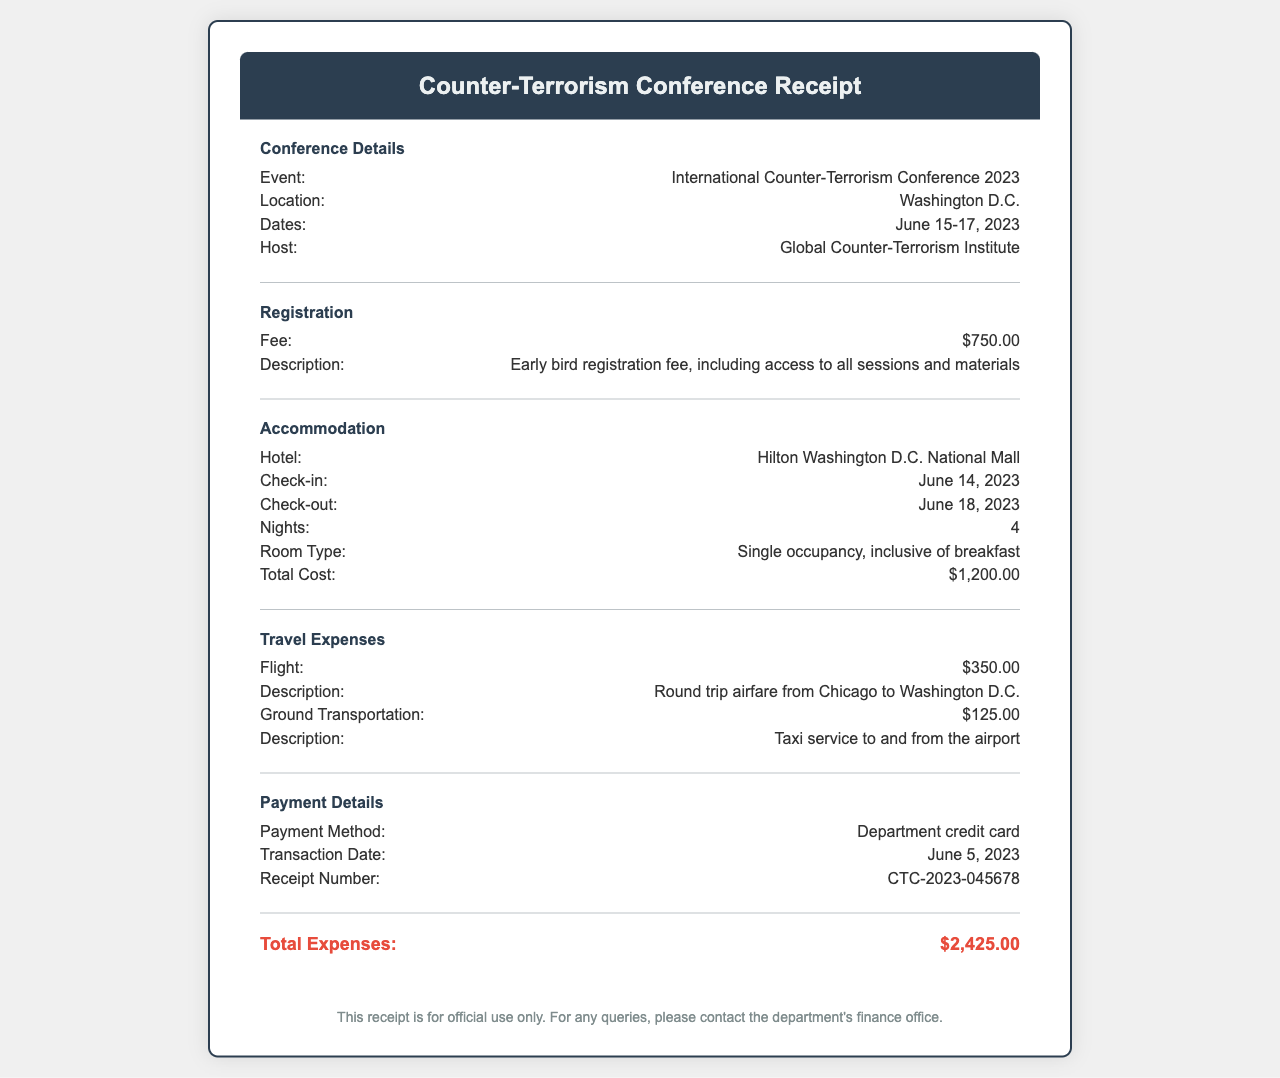What is the event title? The event title is explicitly stated in the document under "Conference Details."
Answer: International Counter-Terrorism Conference 2023 What is the check-out date from the hotel? The check-out date is detailed in the accommodation section of the document.
Answer: June 18, 2023 How much was the registration fee? The amount is clearly listed in the registration section of the receipt.
Answer: $750.00 What is the total cost of accommodation? The total cost is provided in the accommodation section.
Answer: $1,200.00 What flight expenses are listed? The travel expenses section details the flight expense as part of the overall travel costs.
Answer: $350.00 How many nights did the attendee stay at the hotel? The number of nights can be found in the accommodation section of the document.
Answer: 4 What was the payment method used? The payment method is specified in the payment details section of the receipt.
Answer: Department credit card What is the total of all expenses? The total expenses are summed in the document and highlighted in the total section.
Answer: $2,425.00 Who hosted the conference? The host information is provided in the "Conference Details" section of the document.
Answer: Global Counter-Terrorism Institute 